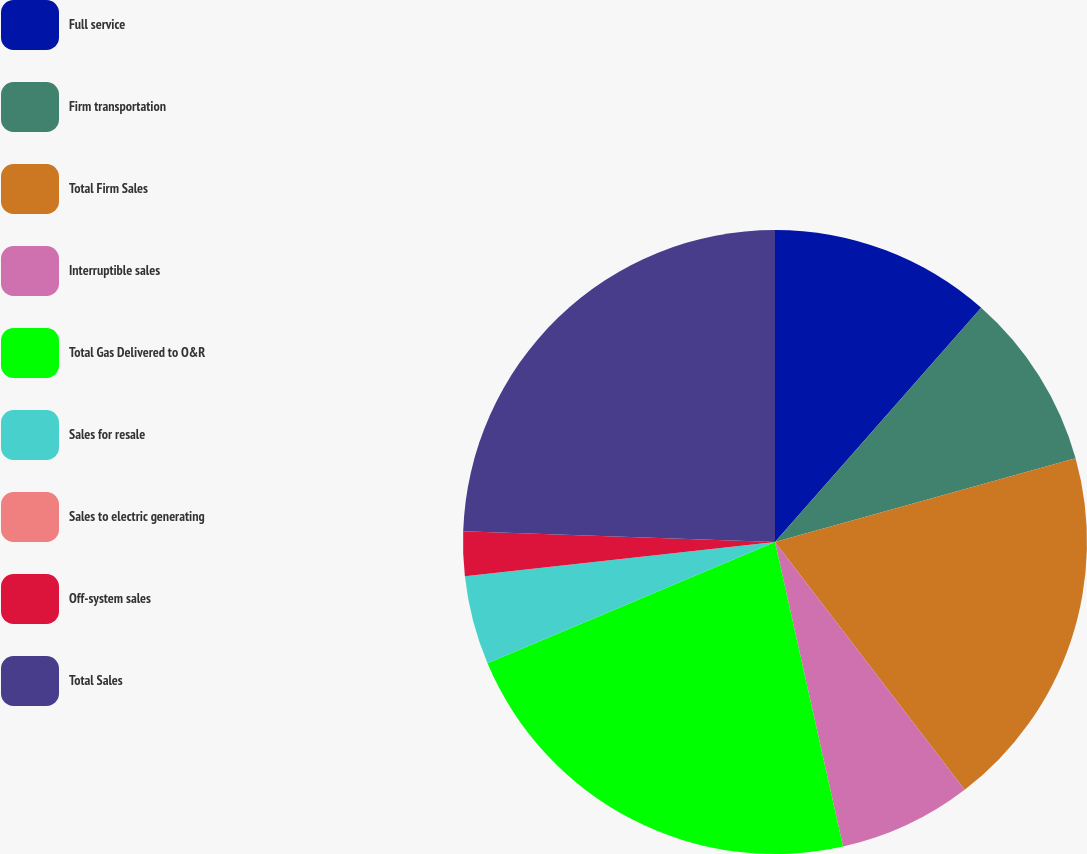<chart> <loc_0><loc_0><loc_500><loc_500><pie_chart><fcel>Full service<fcel>Firm transportation<fcel>Total Firm Sales<fcel>Interruptible sales<fcel>Total Gas Delivered to O&R<fcel>Sales for resale<fcel>Sales to electric generating<fcel>Off-system sales<fcel>Total Sales<nl><fcel>11.49%<fcel>9.19%<fcel>18.92%<fcel>6.9%<fcel>22.15%<fcel>4.6%<fcel>0.0%<fcel>2.3%<fcel>24.45%<nl></chart> 